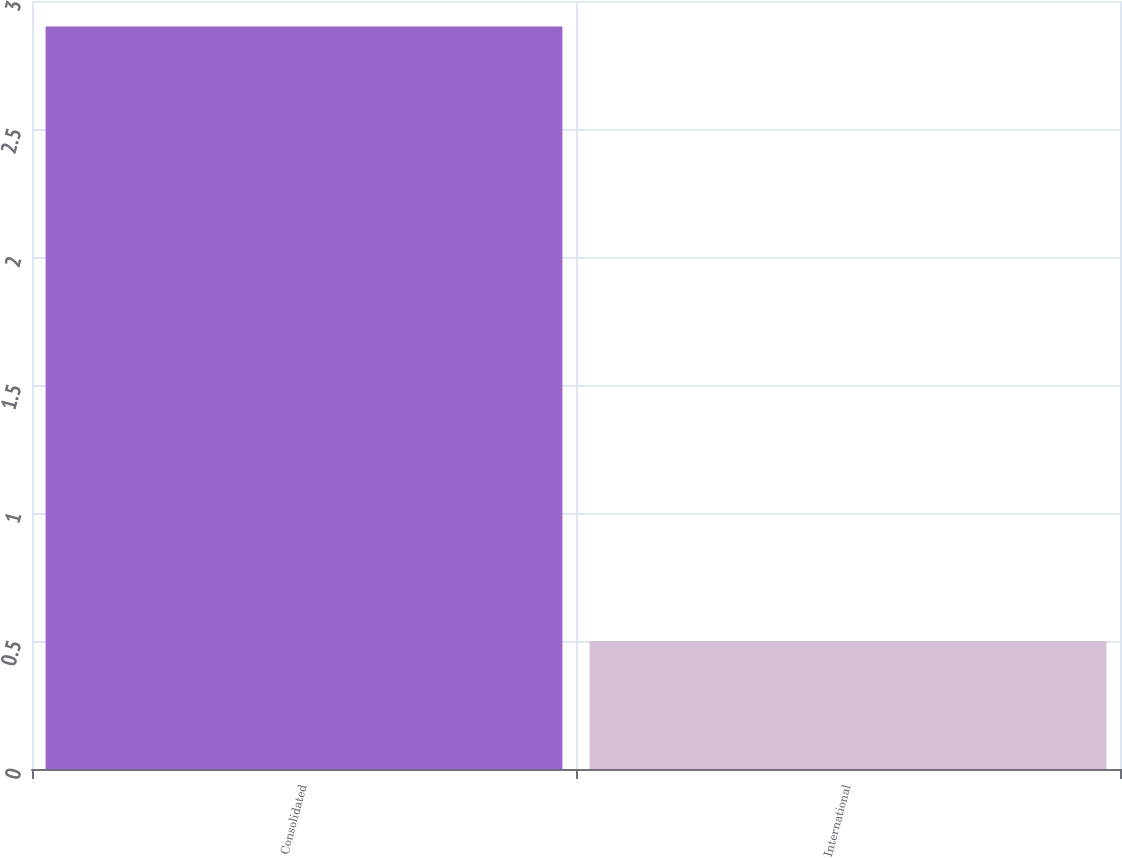Convert chart to OTSL. <chart><loc_0><loc_0><loc_500><loc_500><bar_chart><fcel>Consolidated<fcel>International<nl><fcel>2.9<fcel>0.5<nl></chart> 